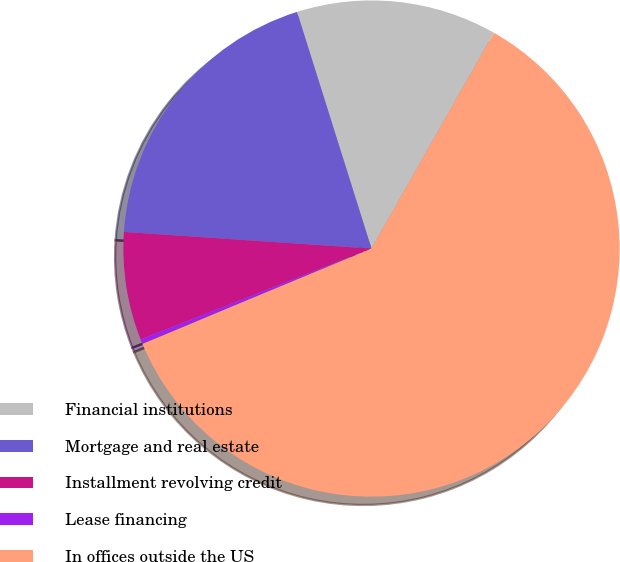Convert chart to OTSL. <chart><loc_0><loc_0><loc_500><loc_500><pie_chart><fcel>Financial institutions<fcel>Mortgage and real estate<fcel>Installment revolving credit<fcel>Lease financing<fcel>In offices outside the US<nl><fcel>13.06%<fcel>19.08%<fcel>7.04%<fcel>0.3%<fcel>60.52%<nl></chart> 